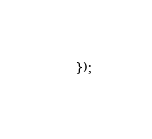Convert code to text. <code><loc_0><loc_0><loc_500><loc_500><_JavaScript_>});
</code> 